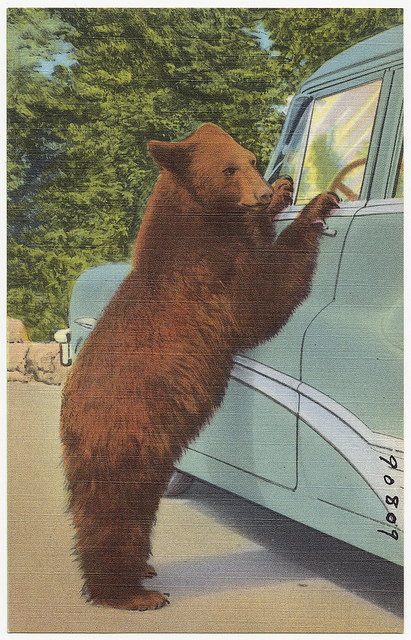<image>What damage could the bear do to the car? It is ambiguous to perfectly predict the damage a bear could do to the car. However, it could possibly scratch the paint or break the window. What damage could the bear do to the car? The bear could potentially break the windows and scratch the car's paint. 